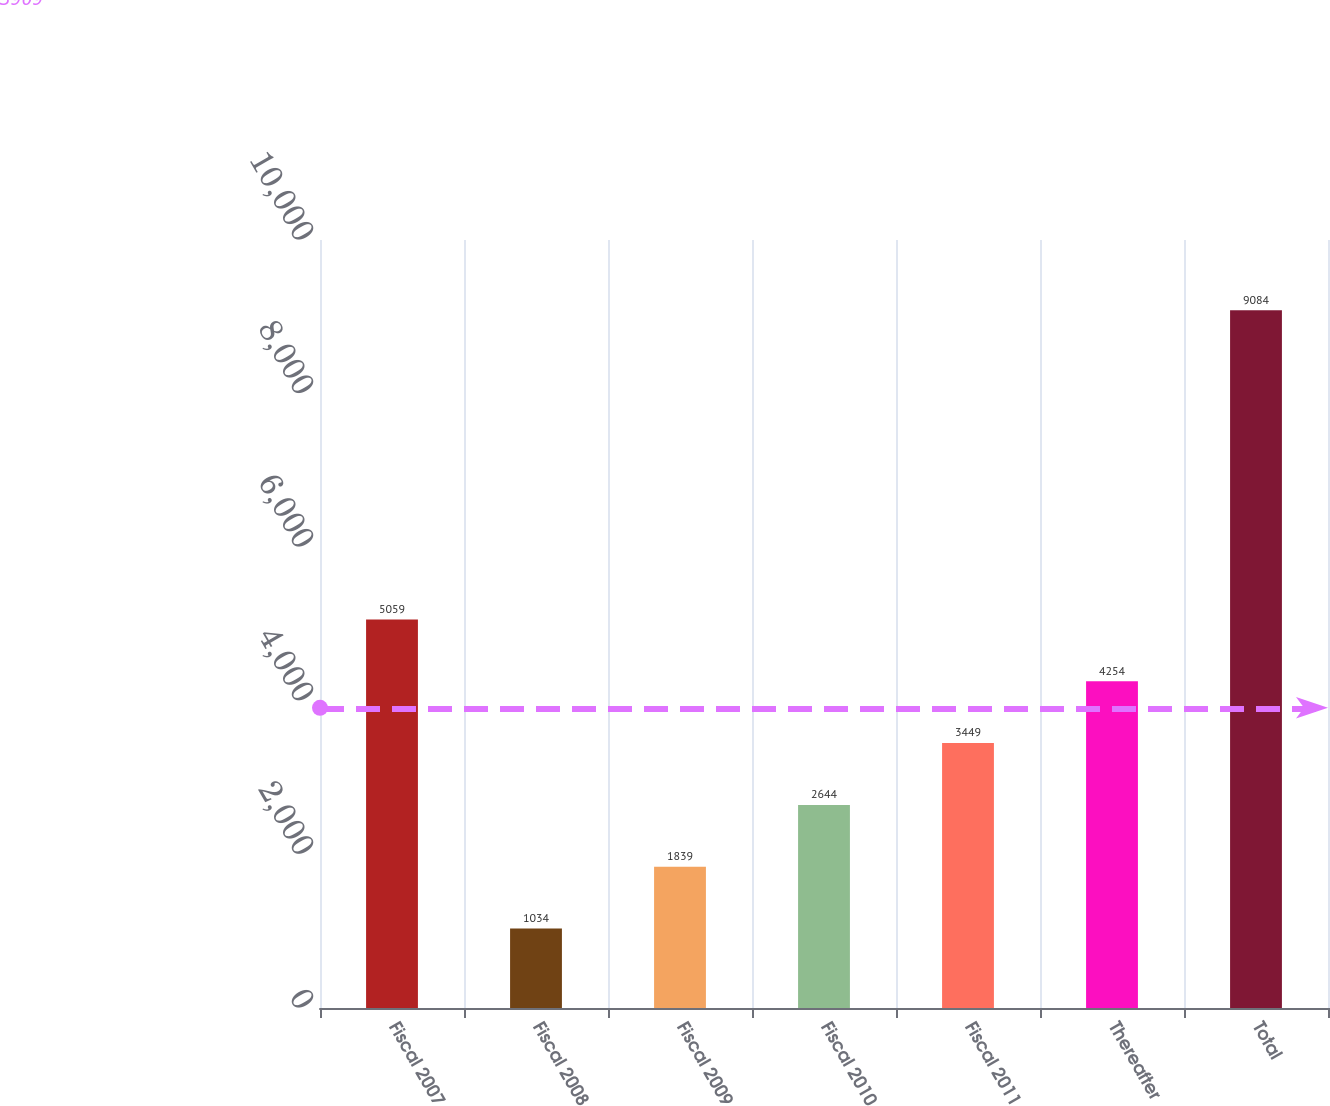<chart> <loc_0><loc_0><loc_500><loc_500><bar_chart><fcel>Fiscal 2007<fcel>Fiscal 2008<fcel>Fiscal 2009<fcel>Fiscal 2010<fcel>Fiscal 2011<fcel>Thereafter<fcel>Total<nl><fcel>5059<fcel>1034<fcel>1839<fcel>2644<fcel>3449<fcel>4254<fcel>9084<nl></chart> 